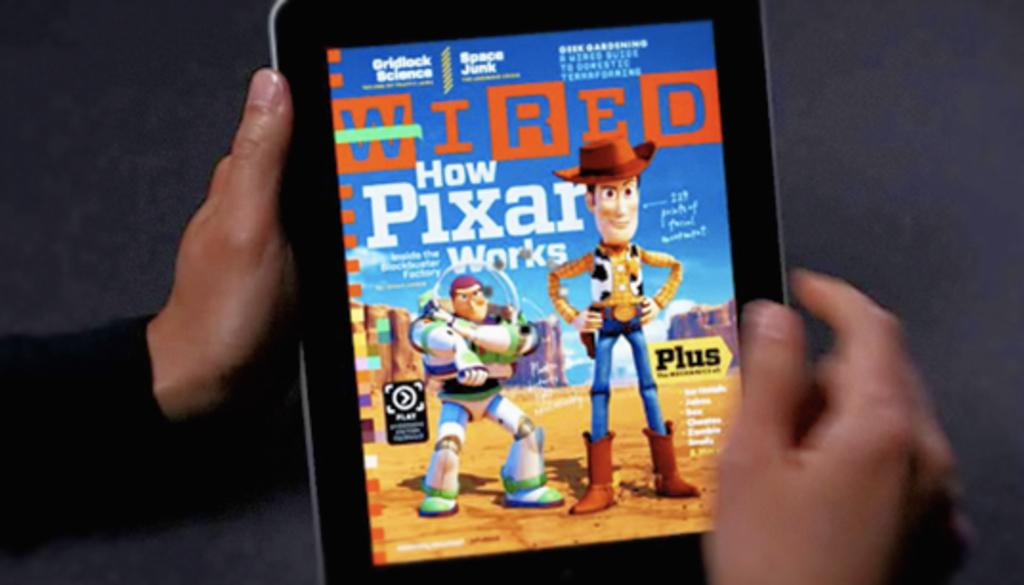Provide a one-sentence caption for the provided image. The digital copy of Wired has an article about Pixar. 